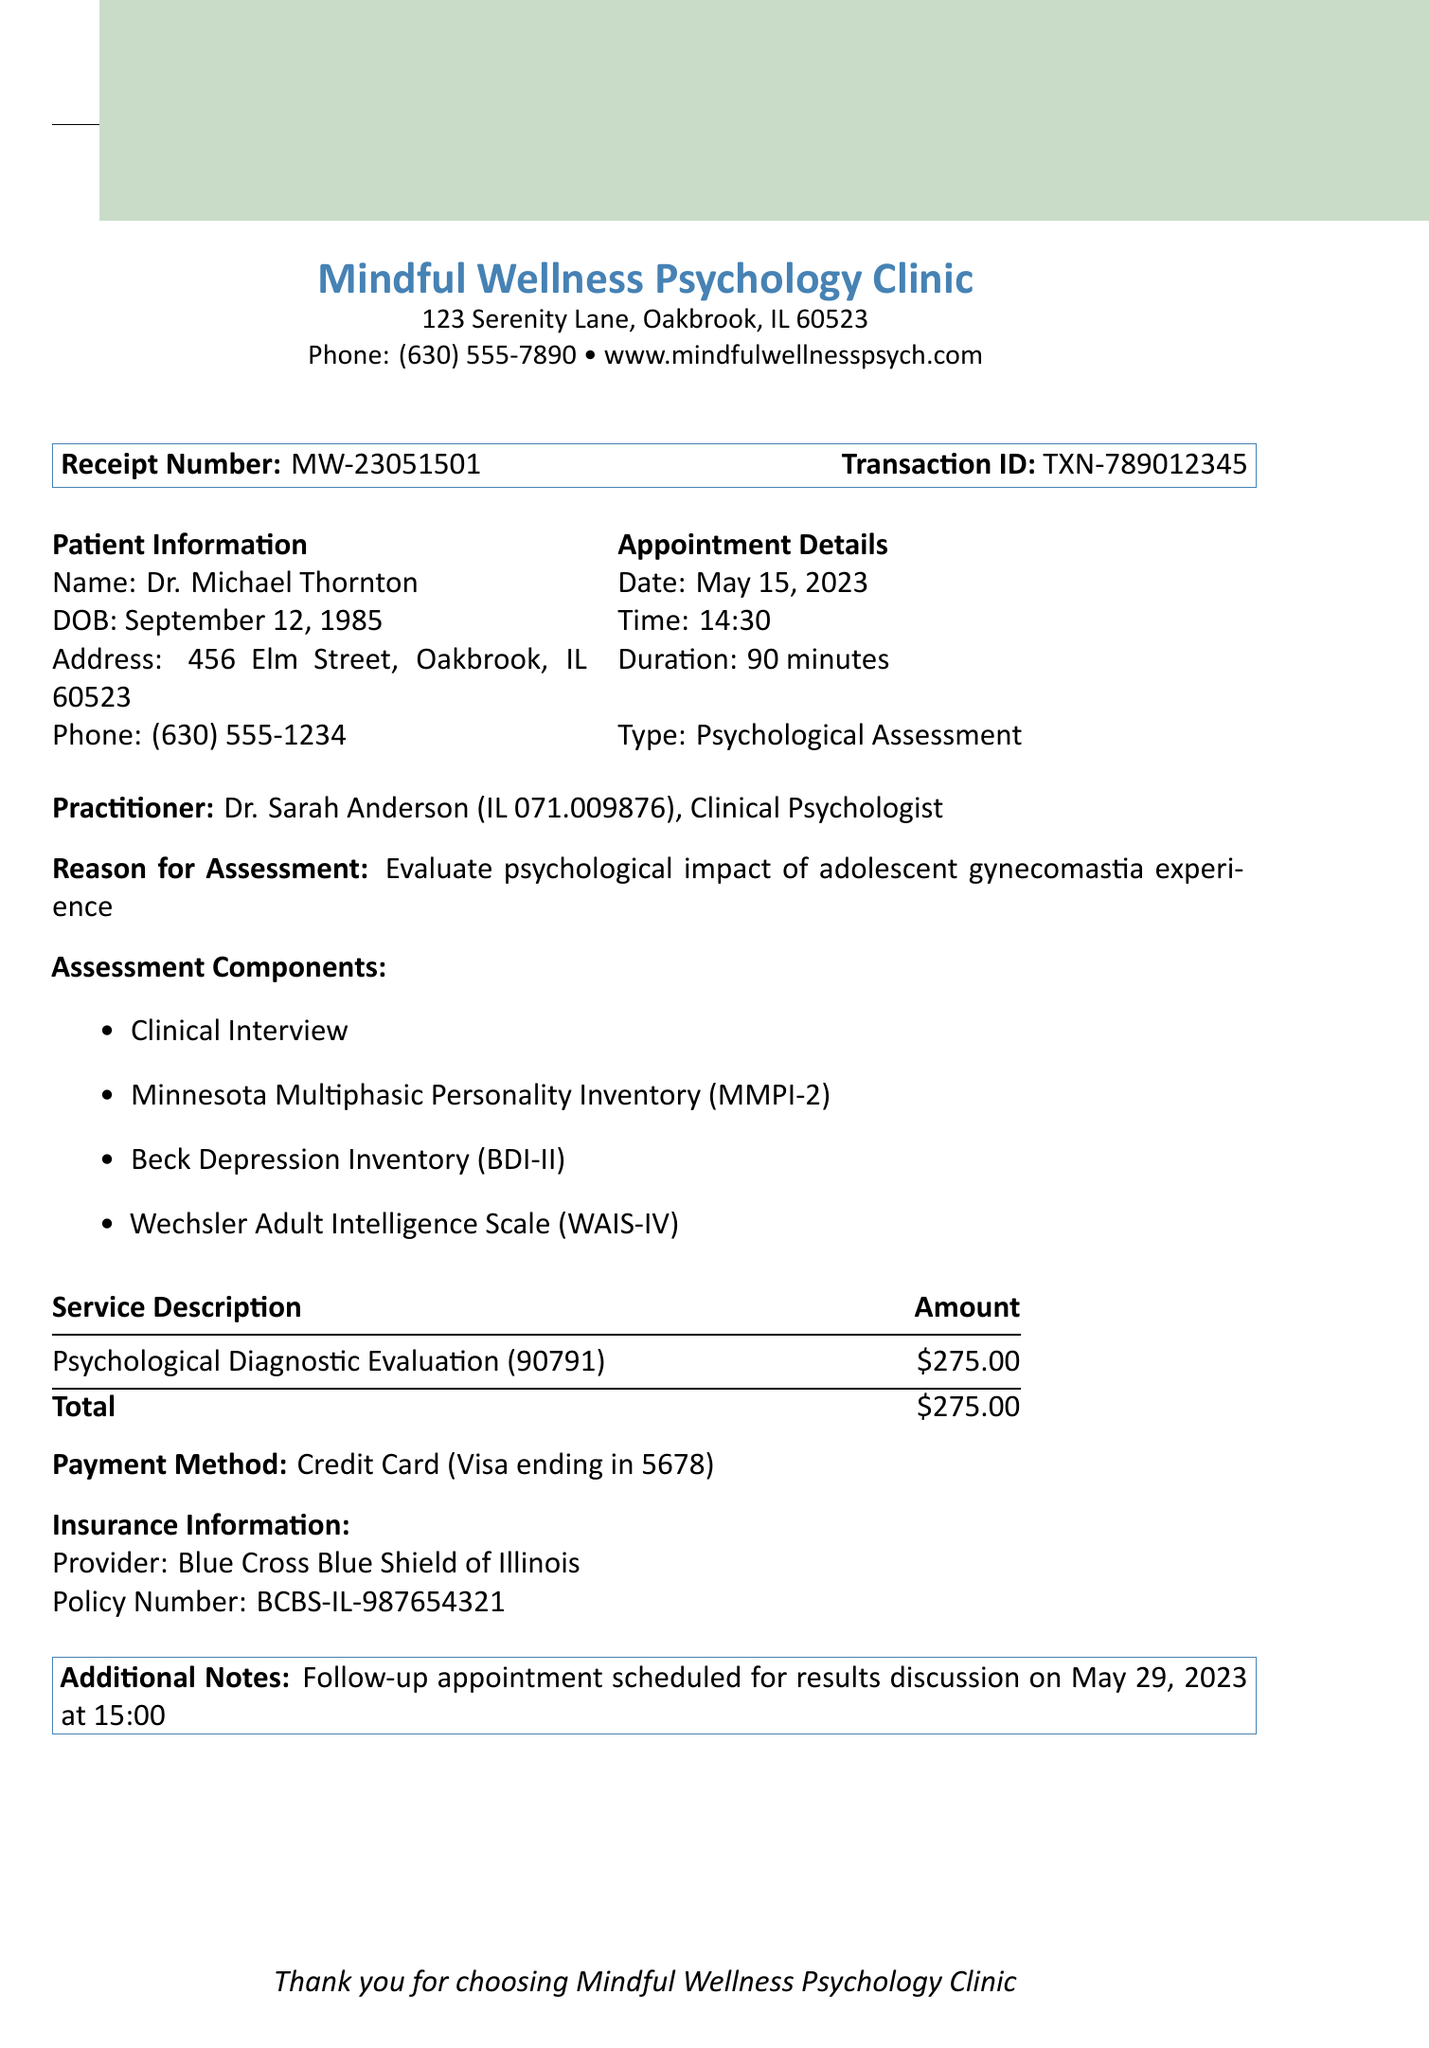What is the name of the clinic? The clinic name is the first part of the document and provides the service provider's identity.
Answer: Mindful Wellness Psychology Clinic Who is the patient? The document identifies the patient at the top of the Patient Information section.
Answer: Dr. Michael Thornton What is the appointment date? The appointment date is clearly stated in the Appointment Details section.
Answer: May 15, 2023 What is the total fee for the service? The total fee is found in the billing details section under the Total line.
Answer: $275.00 What is the reason for the assessment? The reason is specified below the practitioner information and outlines the purpose of the evaluation.
Answer: Evaluate psychological impact of adolescent gynecomastia experience Who is the practitioner? The practitioner is named in the practitioner information section and indicates the professional providing the service.
Answer: Dr. Sarah Anderson What is the payment method? The payment method is detailed in the billing section as part of the financial transaction information.
Answer: Credit Card (Visa ending in 5678) When is the follow-up appointment scheduled? The follow-up appointment information is clearly stated in the additional notes section of the document.
Answer: May 29, 2023 at 15:00 